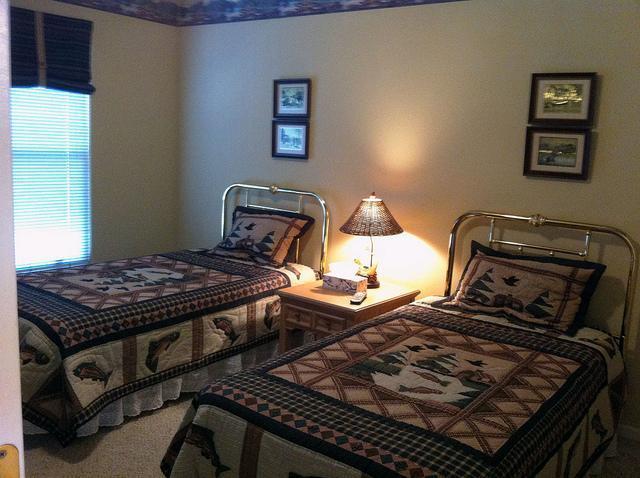How many lights are on in the room?
Give a very brief answer. 1. How many lights are turned on?
Give a very brief answer. 1. How many light fixtures illuminate the painting behind the bed?
Give a very brief answer. 1. How many beds are there?
Give a very brief answer. 2. How many giraffes are visible in this photograph?
Give a very brief answer. 0. 